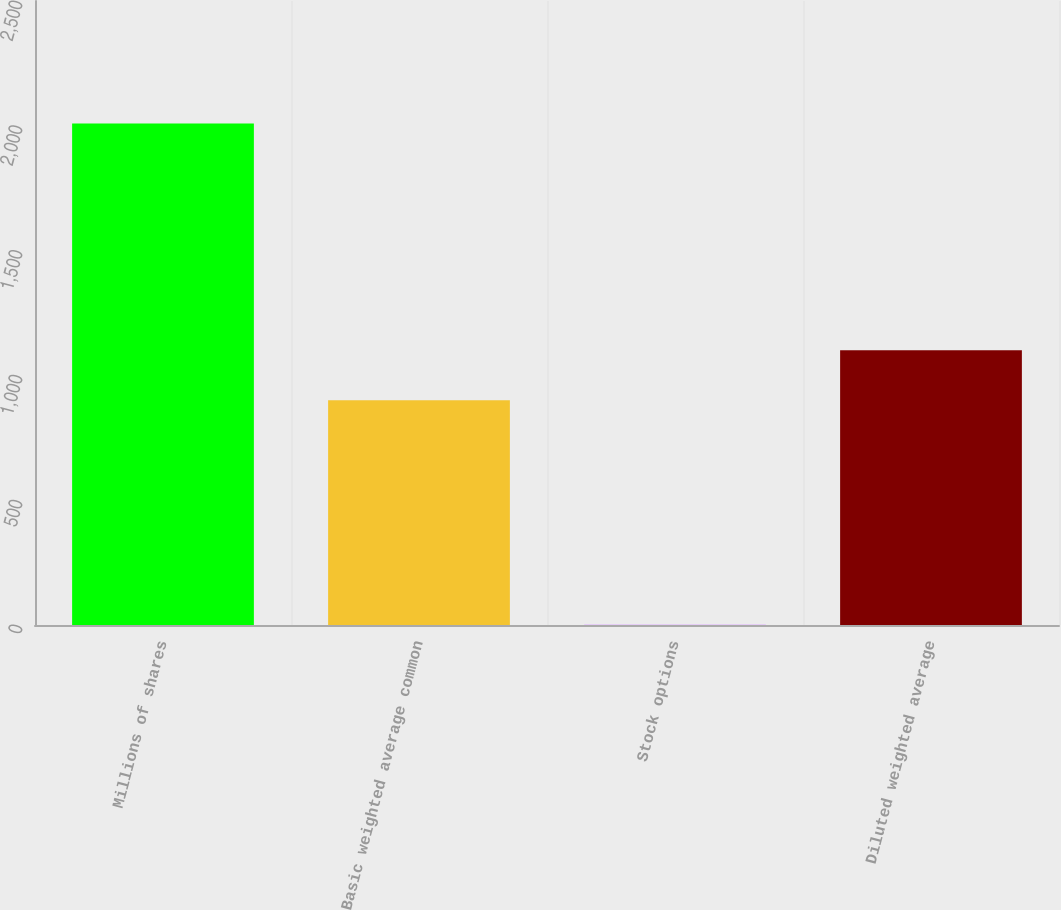Convert chart. <chart><loc_0><loc_0><loc_500><loc_500><bar_chart><fcel>Millions of shares<fcel>Basic weighted average common<fcel>Stock options<fcel>Diluted weighted average<nl><fcel>2009<fcel>900<fcel>2<fcel>1100.7<nl></chart> 